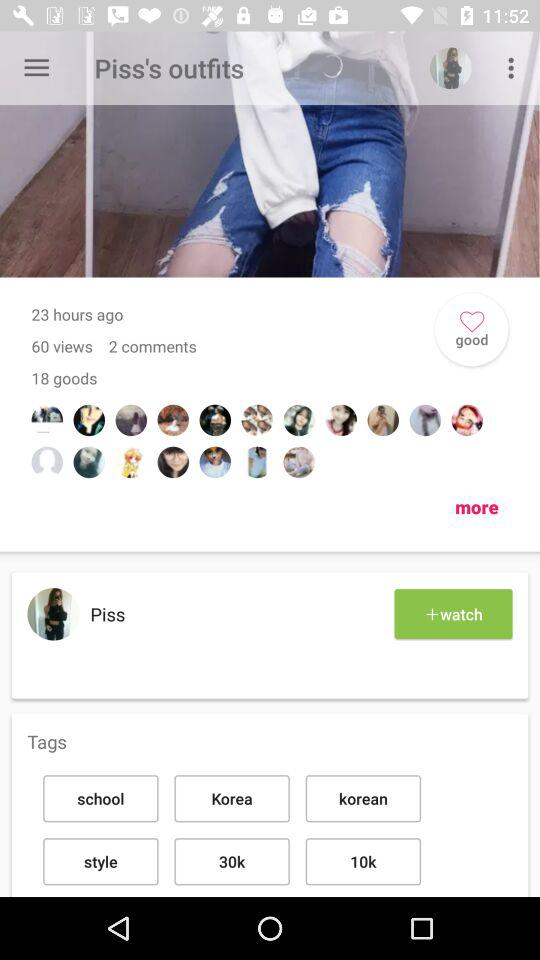How many more goods are there than comments?
Answer the question using a single word or phrase. 16 